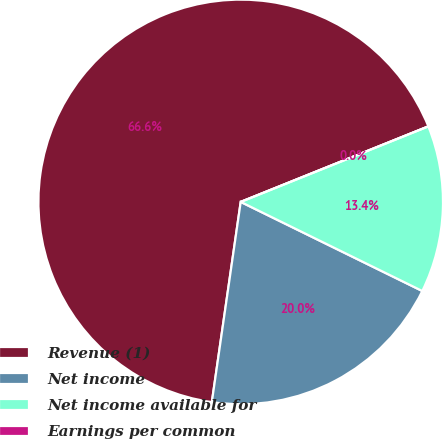Convert chart to OTSL. <chart><loc_0><loc_0><loc_500><loc_500><pie_chart><fcel>Revenue (1)<fcel>Net income<fcel>Net income available for<fcel>Earnings per common<nl><fcel>66.63%<fcel>20.02%<fcel>13.35%<fcel>0.0%<nl></chart> 